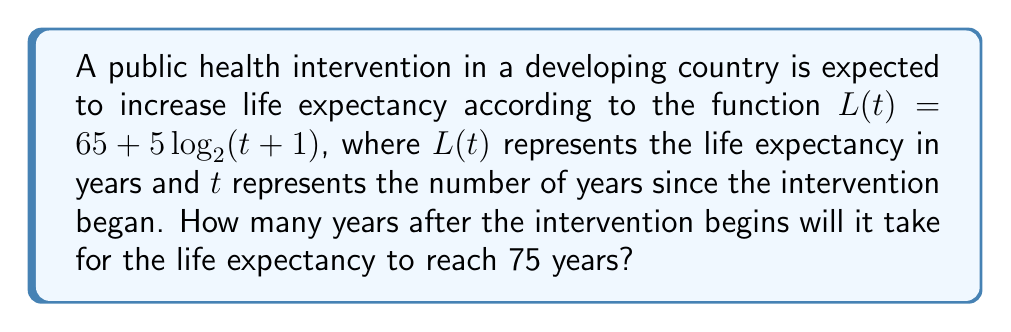Teach me how to tackle this problem. Let's approach this step-by-step:

1) We need to solve the equation:
   $75 = 65 + 5\log_2(t+1)$

2) Subtract 65 from both sides:
   $10 = 5\log_2(t+1)$

3) Divide both sides by 5:
   $2 = \log_2(t+1)$

4) Now, we need to solve for t. We can do this by applying $2^x$ to both sides:
   $2^2 = 2^{\log_2(t+1)}$

5) Simplify the left side:
   $4 = t+1$

6) Subtract 1 from both sides:
   $3 = t$

Therefore, it will take 3 years after the intervention begins for the life expectancy to reach 75 years.
Answer: 3 years 